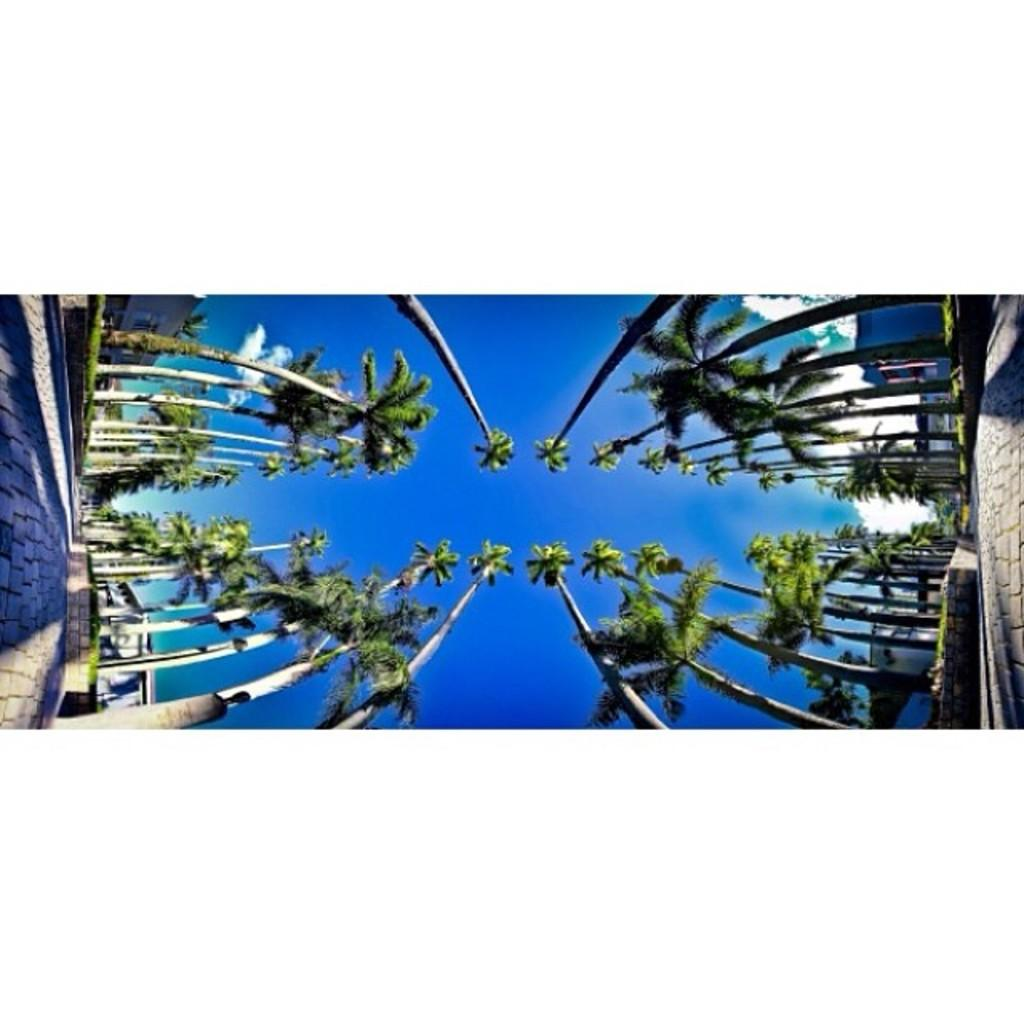What type of vegetation is present in the image? There are green color trees in the image. What color is the sky in the image? The sky is blue in the image. How many children are playing in the image? There are no children present in the image. What type of attention is the tree receiving in the image? The image does not depict any specific attention being given to the tree. 